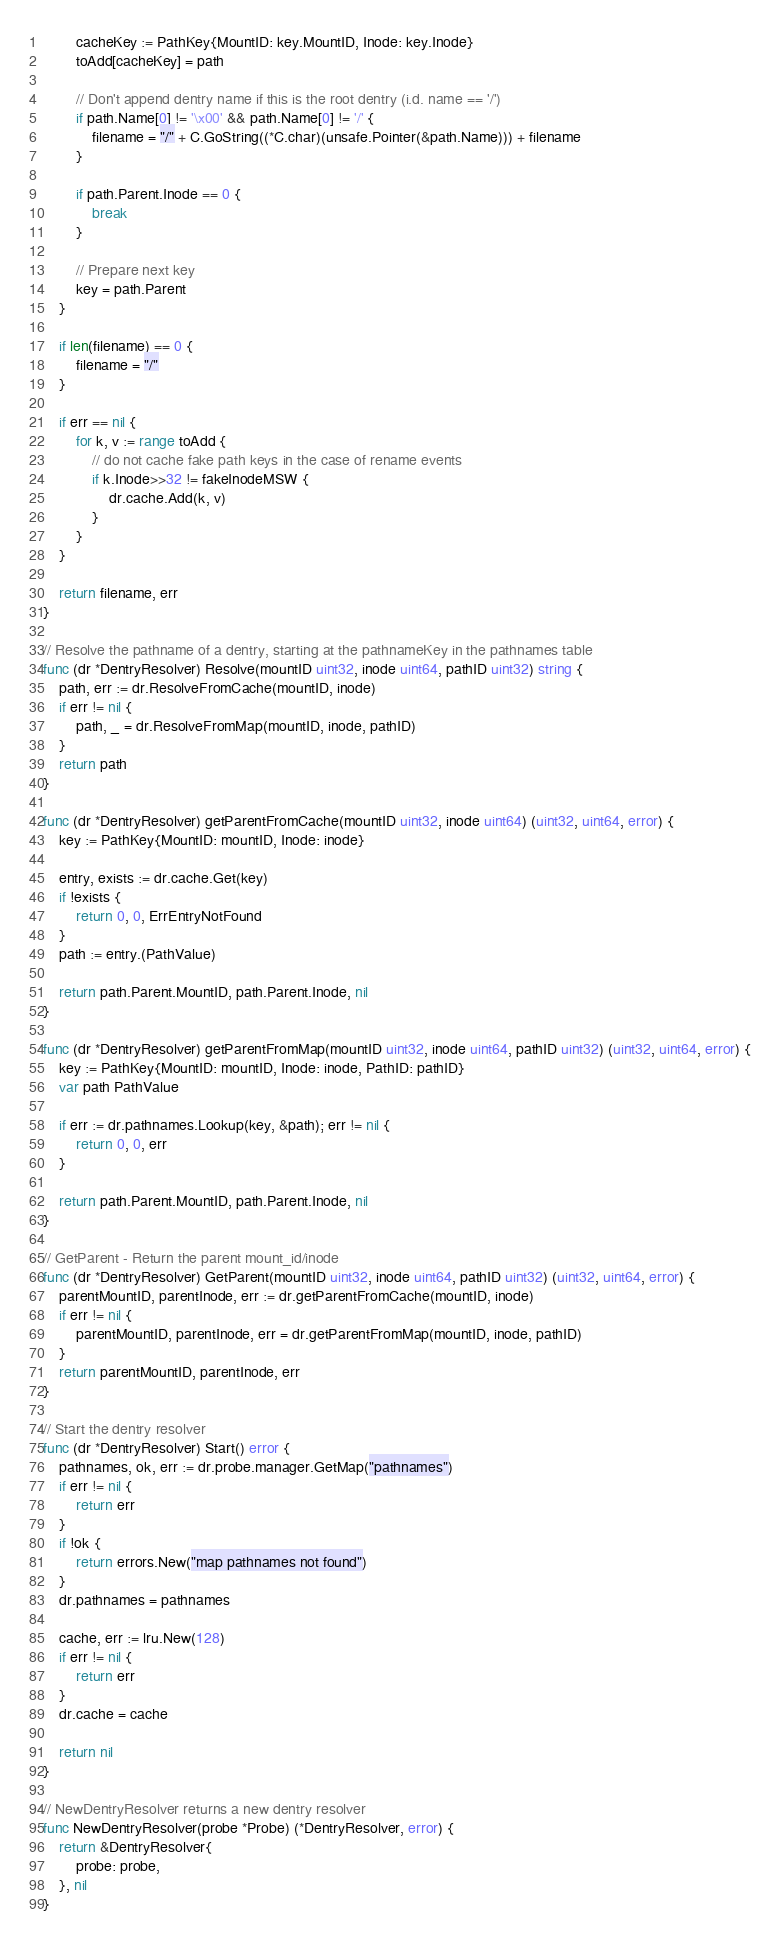<code> <loc_0><loc_0><loc_500><loc_500><_Go_>
		cacheKey := PathKey{MountID: key.MountID, Inode: key.Inode}
		toAdd[cacheKey] = path

		// Don't append dentry name if this is the root dentry (i.d. name == '/')
		if path.Name[0] != '\x00' && path.Name[0] != '/' {
			filename = "/" + C.GoString((*C.char)(unsafe.Pointer(&path.Name))) + filename
		}

		if path.Parent.Inode == 0 {
			break
		}

		// Prepare next key
		key = path.Parent
	}

	if len(filename) == 0 {
		filename = "/"
	}

	if err == nil {
		for k, v := range toAdd {
			// do not cache fake path keys in the case of rename events
			if k.Inode>>32 != fakeInodeMSW {
				dr.cache.Add(k, v)
			}
		}
	}

	return filename, err
}

// Resolve the pathname of a dentry, starting at the pathnameKey in the pathnames table
func (dr *DentryResolver) Resolve(mountID uint32, inode uint64, pathID uint32) string {
	path, err := dr.ResolveFromCache(mountID, inode)
	if err != nil {
		path, _ = dr.ResolveFromMap(mountID, inode, pathID)
	}
	return path
}

func (dr *DentryResolver) getParentFromCache(mountID uint32, inode uint64) (uint32, uint64, error) {
	key := PathKey{MountID: mountID, Inode: inode}

	entry, exists := dr.cache.Get(key)
	if !exists {
		return 0, 0, ErrEntryNotFound
	}
	path := entry.(PathValue)

	return path.Parent.MountID, path.Parent.Inode, nil
}

func (dr *DentryResolver) getParentFromMap(mountID uint32, inode uint64, pathID uint32) (uint32, uint64, error) {
	key := PathKey{MountID: mountID, Inode: inode, PathID: pathID}
	var path PathValue

	if err := dr.pathnames.Lookup(key, &path); err != nil {
		return 0, 0, err
	}

	return path.Parent.MountID, path.Parent.Inode, nil
}

// GetParent - Return the parent mount_id/inode
func (dr *DentryResolver) GetParent(mountID uint32, inode uint64, pathID uint32) (uint32, uint64, error) {
	parentMountID, parentInode, err := dr.getParentFromCache(mountID, inode)
	if err != nil {
		parentMountID, parentInode, err = dr.getParentFromMap(mountID, inode, pathID)
	}
	return parentMountID, parentInode, err
}

// Start the dentry resolver
func (dr *DentryResolver) Start() error {
	pathnames, ok, err := dr.probe.manager.GetMap("pathnames")
	if err != nil {
		return err
	}
	if !ok {
		return errors.New("map pathnames not found")
	}
	dr.pathnames = pathnames

	cache, err := lru.New(128)
	if err != nil {
		return err
	}
	dr.cache = cache

	return nil
}

// NewDentryResolver returns a new dentry resolver
func NewDentryResolver(probe *Probe) (*DentryResolver, error) {
	return &DentryResolver{
		probe: probe,
	}, nil
}
</code> 